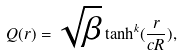Convert formula to latex. <formula><loc_0><loc_0><loc_500><loc_500>Q ( r ) = \sqrt { \beta } \tanh ^ { k } ( \frac { r } { c R } ) ,</formula> 